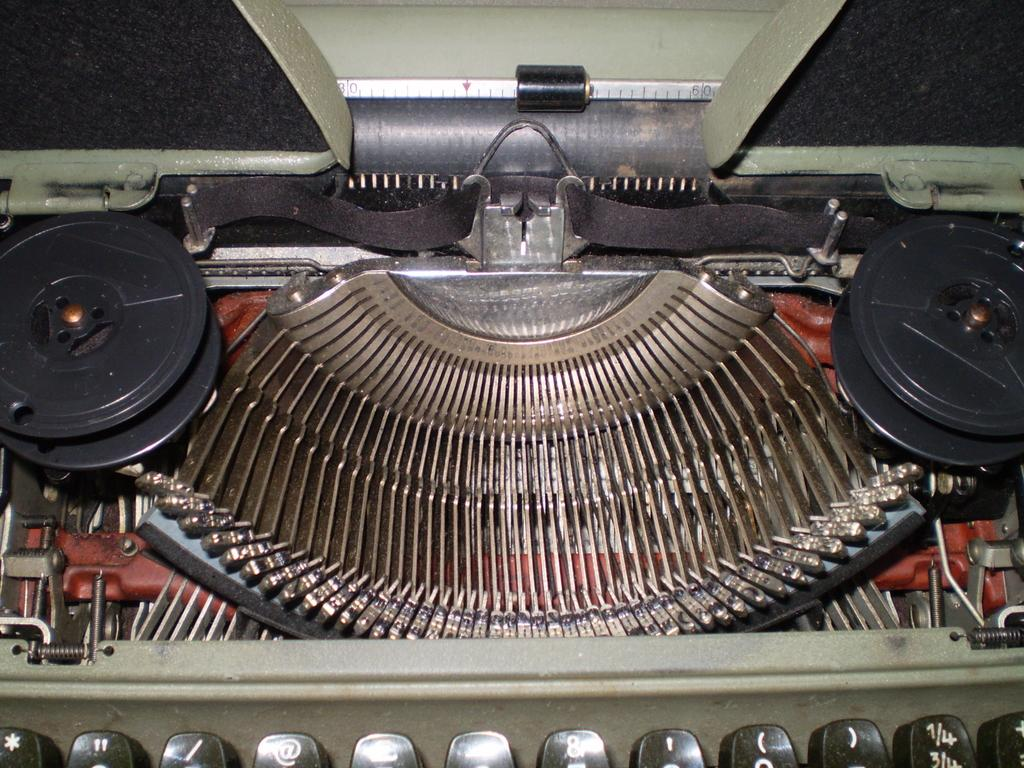What is the main object in the picture? There is a typewriter machine in the picture. What is a feature of the typewriter? The typewriter has a ribbon spool. What are the parts on the typewriter that you press to type? The typewriter has key tops. What color are some of the keys on the typewriter? Some keys on the typewriter are black in color. What type of bun is being used to hold the typewriter in place? There is no bun present in the image, and the typewriter is not being held in place by any object. How many police officers are visible in the image? There are no police officers present in the image; it features a typewriter machine. 